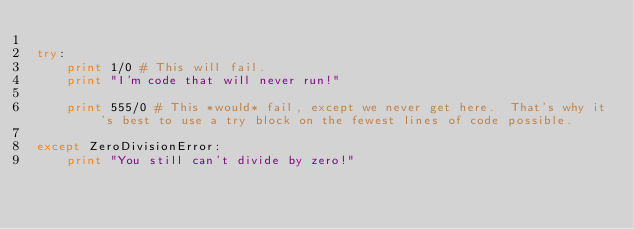Convert code to text. <code><loc_0><loc_0><loc_500><loc_500><_Python_>
try:
    print 1/0 # This will fail.
    print "I'm code that will never run!"

    print 555/0 # This *would* fail, except we never get here.  That's why it's best to use a try block on the fewest lines of code possible.

except ZeroDivisionError:
    print "You still can't divide by zero!"
</code> 